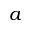Convert formula to latex. <formula><loc_0><loc_0><loc_500><loc_500>a</formula> 